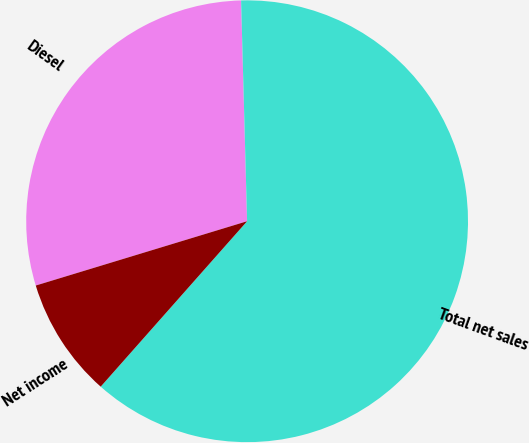<chart> <loc_0><loc_0><loc_500><loc_500><pie_chart><fcel>Diesel<fcel>Total net sales<fcel>Net income<nl><fcel>29.27%<fcel>61.97%<fcel>8.77%<nl></chart> 